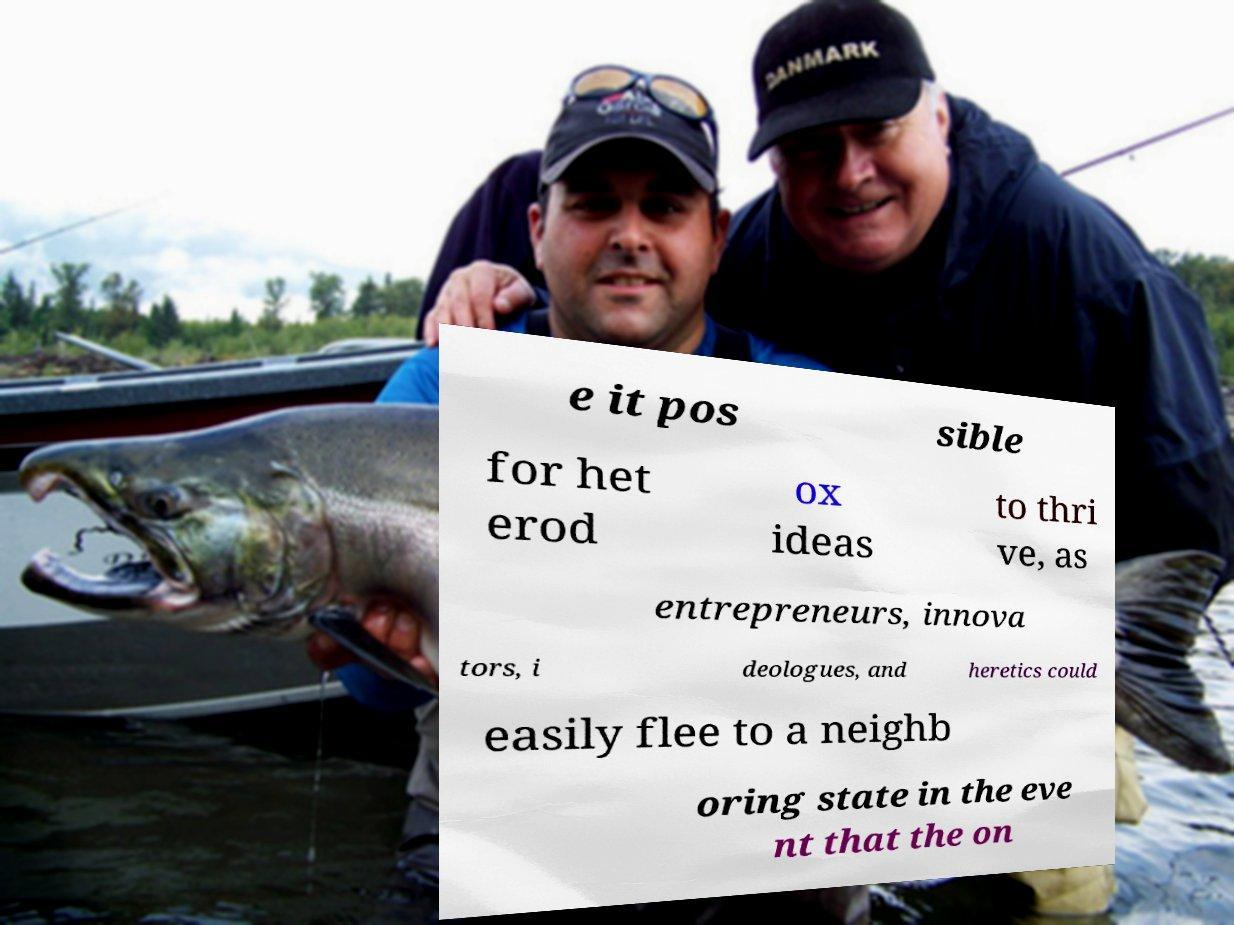Could you assist in decoding the text presented in this image and type it out clearly? e it pos sible for het erod ox ideas to thri ve, as entrepreneurs, innova tors, i deologues, and heretics could easily flee to a neighb oring state in the eve nt that the on 